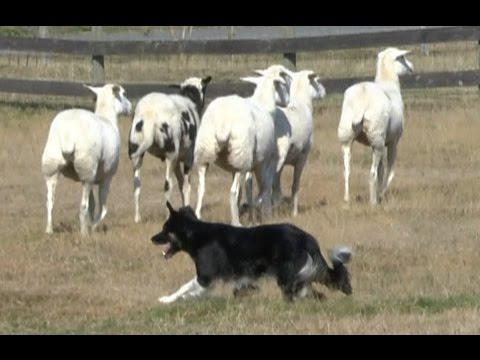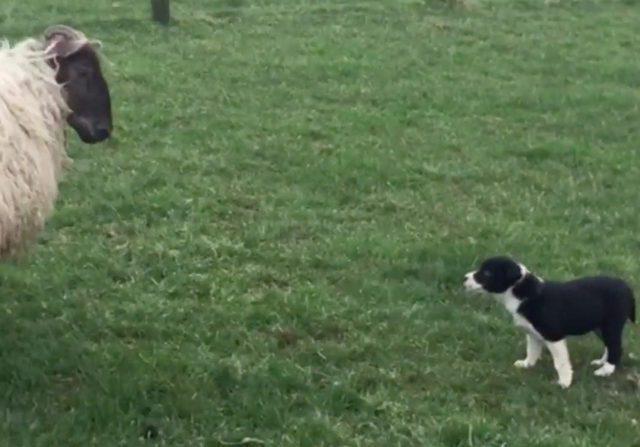The first image is the image on the left, the second image is the image on the right. Given the left and right images, does the statement "An image shows the dog in profile, centered in front of a group of animals." hold true? Answer yes or no. Yes. The first image is the image on the left, the second image is the image on the right. Analyze the images presented: Is the assertion "The sheep in the image on the left have been shorn." valid? Answer yes or no. Yes. 